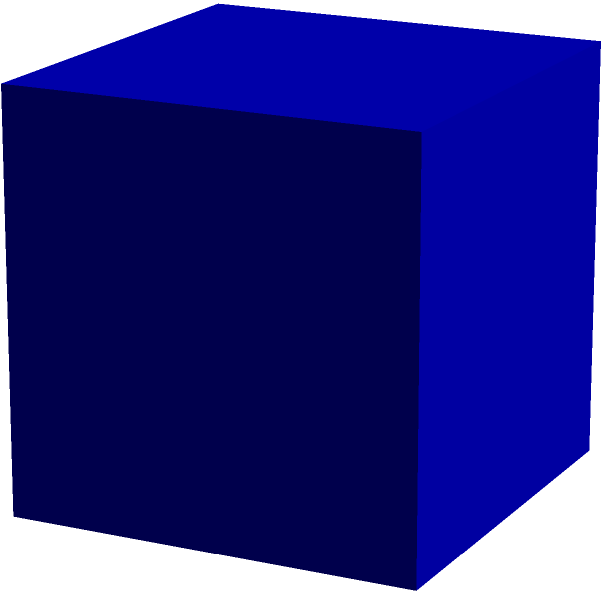Consider a unit cube being cut by a plane parallel to the xy-plane at $z = 0.7$. What shape will the cross-section of the cube be, and what will be its area? Let's approach this step-by-step:

1) First, we need to visualize the cube and the cutting plane. The cube has dimensions 1x1x1, and the plane is parallel to the xy-plane at $z = 0.7$.

2) Since the cutting plane is parallel to the xy-plane, it will intersect the cube in a shape that's parallel to the base of the cube.

3) The base of a cube is a square, so the cross-section will also be a square.

4) To find the area of this square, we need to determine its side length. 

5) The side length of this square will be the same as the side length of the cube at $z = 0.7$.

6) At $z = 0$, the side length is 1. At $z = 1$, the side length is also 1 (it's a cube, after all).

7) At $z = 0.7$, the side length will still be 1, because the sides of a cube are vertical and don't change length as we move up or down.

8) Therefore, the cross-section is a square with side length 1.

9) The area of a square is the square of its side length. So the area is $1^2 = 1$.

This problem tests spatial reasoning skills, which are valuable for understanding investment concepts like diversification (spreading investments across different "dimensions" of the market). It also involves basic geometry and algebra, skills that are useful for calculating compound interest or analyzing financial data.
Answer: A square with area 1 square unit 